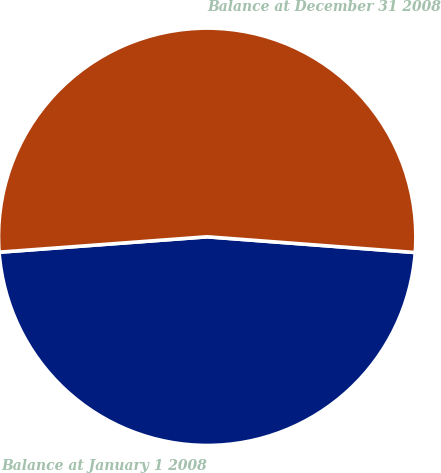Convert chart. <chart><loc_0><loc_0><loc_500><loc_500><pie_chart><fcel>Balance at January 1 2008<fcel>Balance at December 31 2008<nl><fcel>47.62%<fcel>52.38%<nl></chart> 